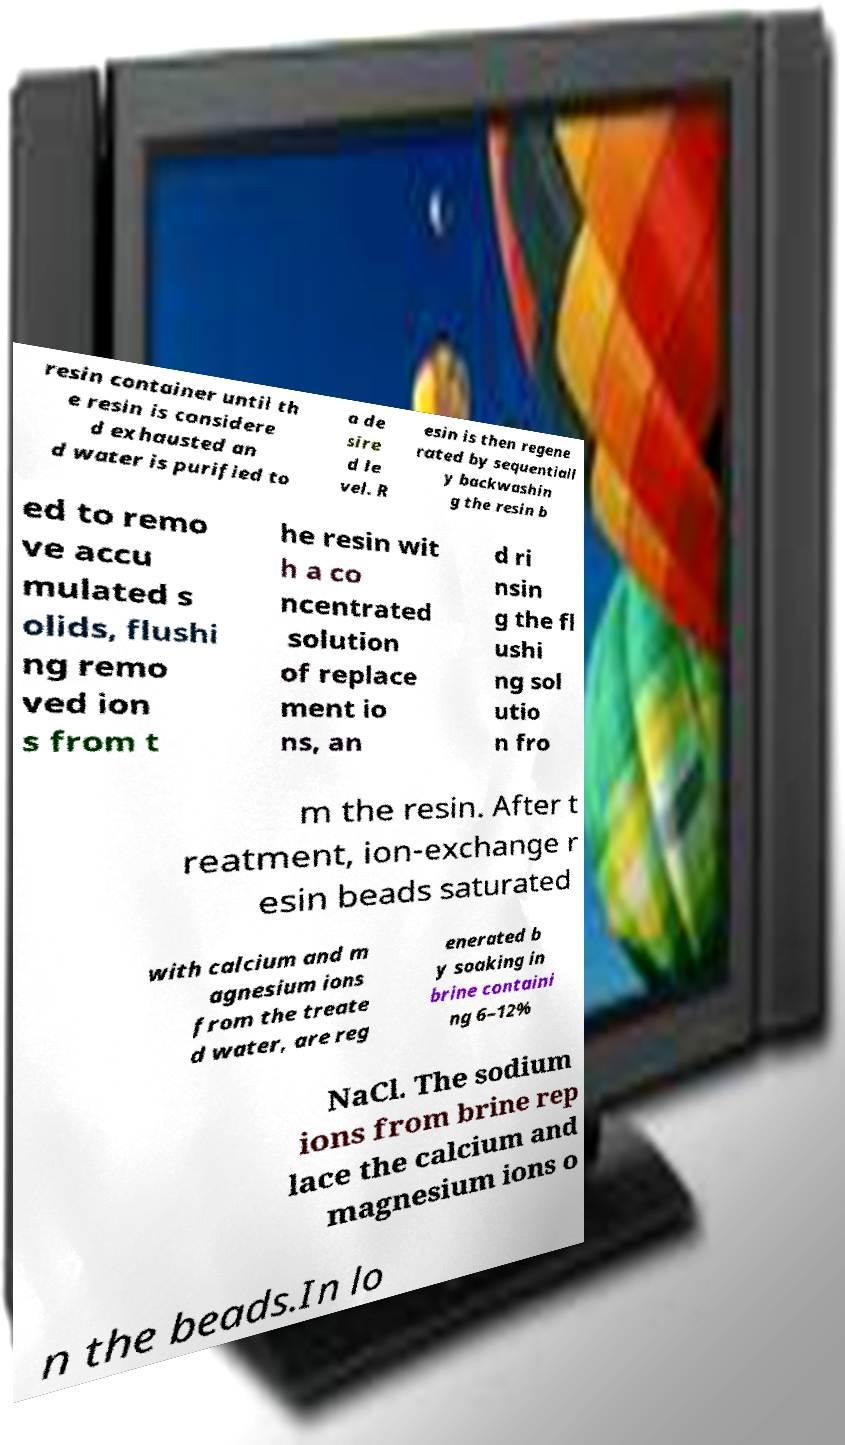Can you read and provide the text displayed in the image?This photo seems to have some interesting text. Can you extract and type it out for me? resin container until th e resin is considere d exhausted an d water is purified to a de sire d le vel. R esin is then regene rated by sequentiall y backwashin g the resin b ed to remo ve accu mulated s olids, flushi ng remo ved ion s from t he resin wit h a co ncentrated solution of replace ment io ns, an d ri nsin g the fl ushi ng sol utio n fro m the resin. After t reatment, ion-exchange r esin beads saturated with calcium and m agnesium ions from the treate d water, are reg enerated b y soaking in brine containi ng 6–12% NaCl. The sodium ions from brine rep lace the calcium and magnesium ions o n the beads.In lo 